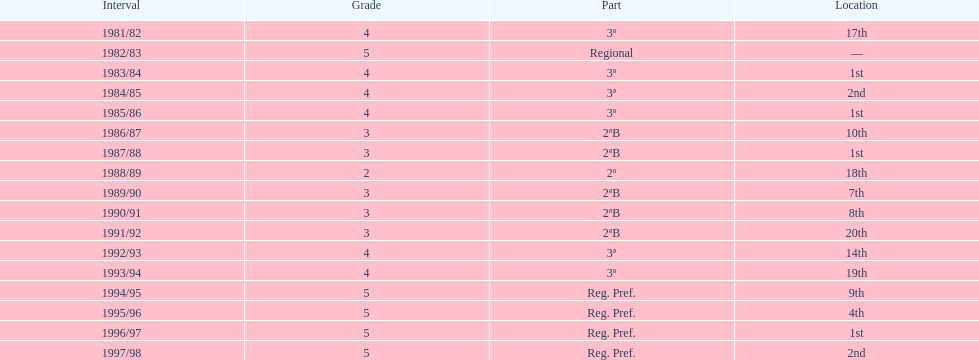In which year did the team have its worst season? 1991/92. Give me the full table as a dictionary. {'header': ['Interval', 'Grade', 'Part', 'Location'], 'rows': [['1981/82', '4', '3ª', '17th'], ['1982/83', '5', 'Regional', '—'], ['1983/84', '4', '3ª', '1st'], ['1984/85', '4', '3ª', '2nd'], ['1985/86', '4', '3ª', '1st'], ['1986/87', '3', '2ªB', '10th'], ['1987/88', '3', '2ªB', '1st'], ['1988/89', '2', '2ª', '18th'], ['1989/90', '3', '2ªB', '7th'], ['1990/91', '3', '2ªB', '8th'], ['1991/92', '3', '2ªB', '20th'], ['1992/93', '4', '3ª', '14th'], ['1993/94', '4', '3ª', '19th'], ['1994/95', '5', 'Reg. Pref.', '9th'], ['1995/96', '5', 'Reg. Pref.', '4th'], ['1996/97', '5', 'Reg. Pref.', '1st'], ['1997/98', '5', 'Reg. Pref.', '2nd']]} 